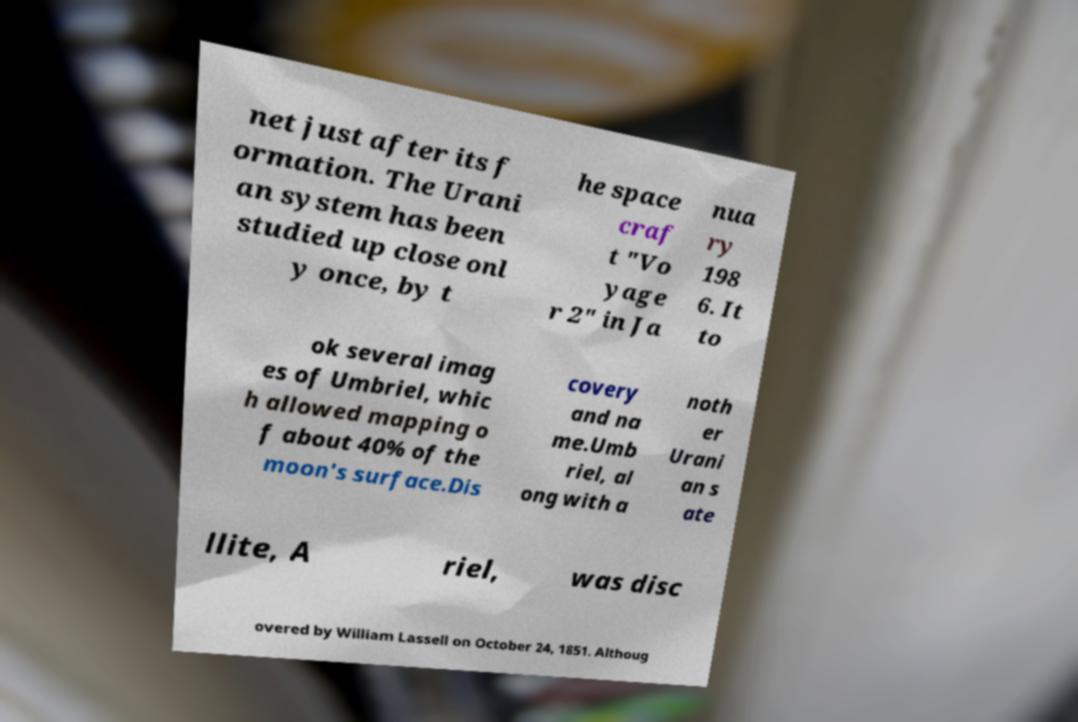What messages or text are displayed in this image? I need them in a readable, typed format. net just after its f ormation. The Urani an system has been studied up close onl y once, by t he space craf t "Vo yage r 2" in Ja nua ry 198 6. It to ok several imag es of Umbriel, whic h allowed mapping o f about 40% of the moon's surface.Dis covery and na me.Umb riel, al ong with a noth er Urani an s ate llite, A riel, was disc overed by William Lassell on October 24, 1851. Althoug 